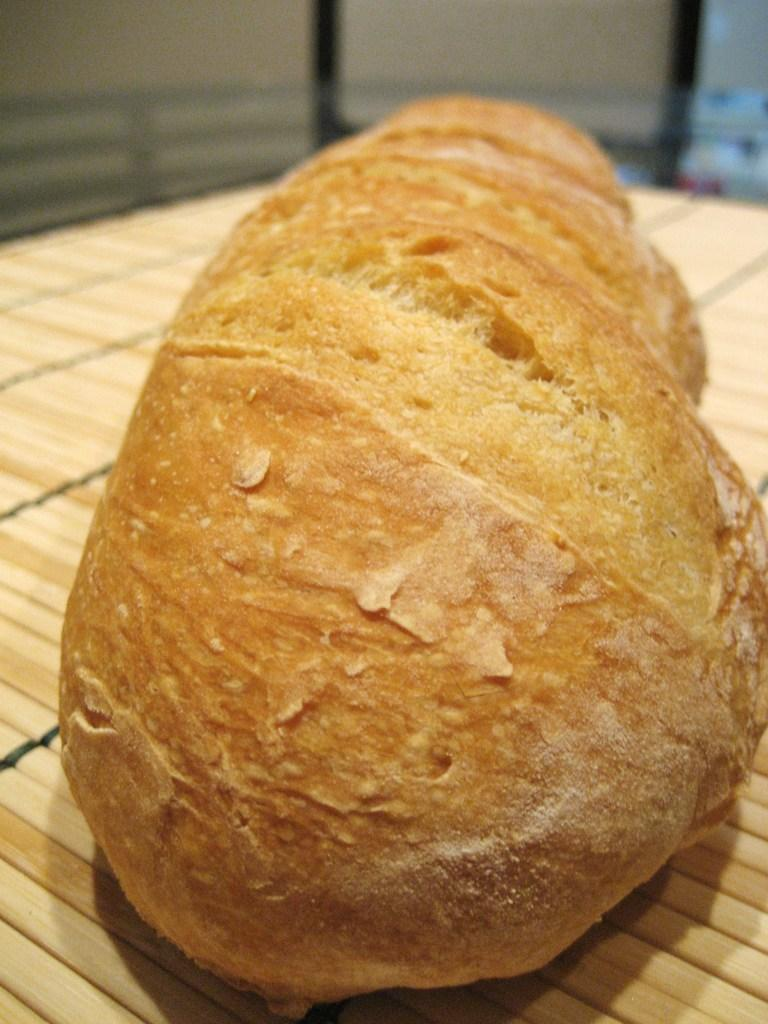What type of food is visible in the image? There is a bread in the image. Where is the bread located? The bread is placed on a mat. How many brothers are depicted in the image? There are no brothers present in the image; it only features a bread on a mat. What is the bread measuring in the image? The bread is not measuring anything in the image; it is simply placed on a mat. 